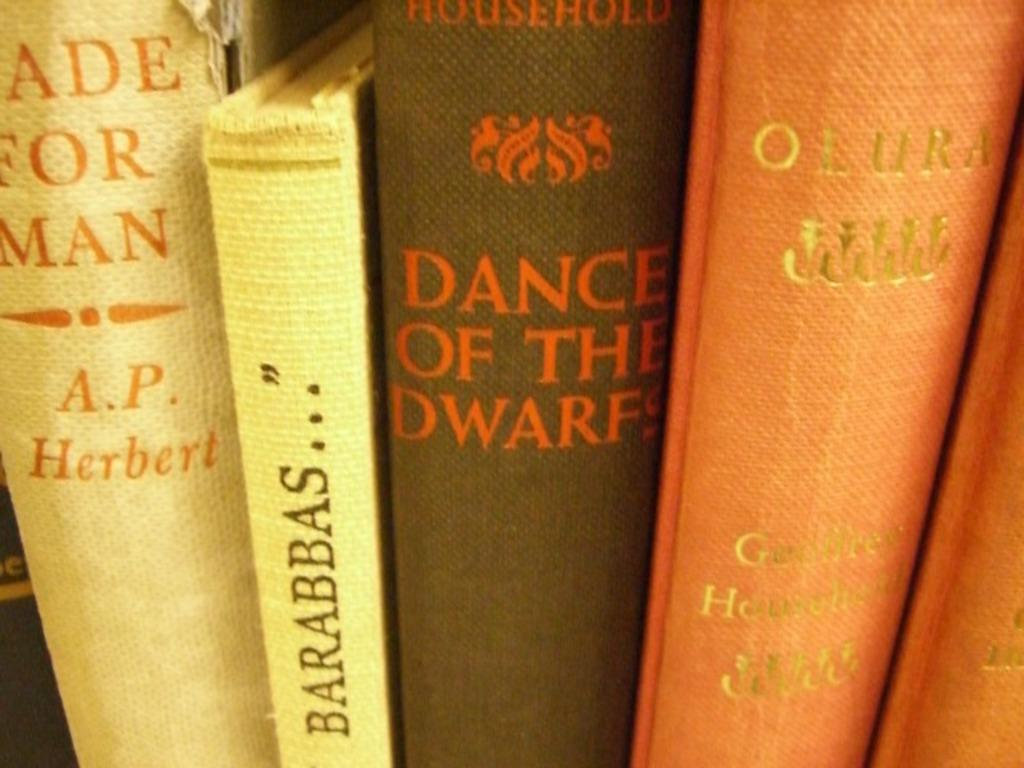Provide a one-sentence caption for the provided image. Dance of the Dwarfs sit in between four other books. 